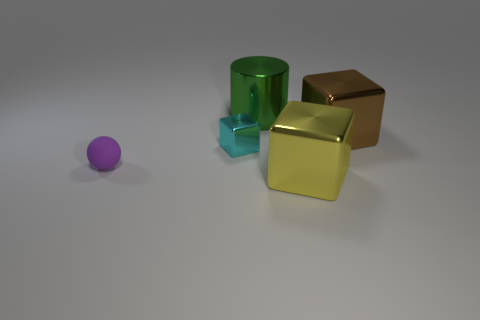What could the different colors of the objects represent? If we interpret the colors symbolically, we could say the purple sphere might represent creativity or luxury, the green cylinder solidity or growth, the blue cube trust or tranquility, and the metallic cubes could signify wealth or industrial strength. 